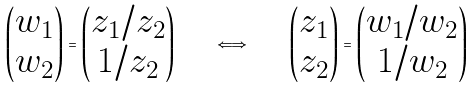<formula> <loc_0><loc_0><loc_500><loc_500>\begin{pmatrix} w _ { 1 } \\ w _ { 2 } \end{pmatrix} = \begin{pmatrix} z _ { 1 } / z _ { 2 } \\ 1 / z _ { 2 } \end{pmatrix} \quad \iff \quad \begin{pmatrix} z _ { 1 } \\ z _ { 2 } \end{pmatrix} = \begin{pmatrix} w _ { 1 } / w _ { 2 } \\ 1 / w _ { 2 } \end{pmatrix}</formula> 